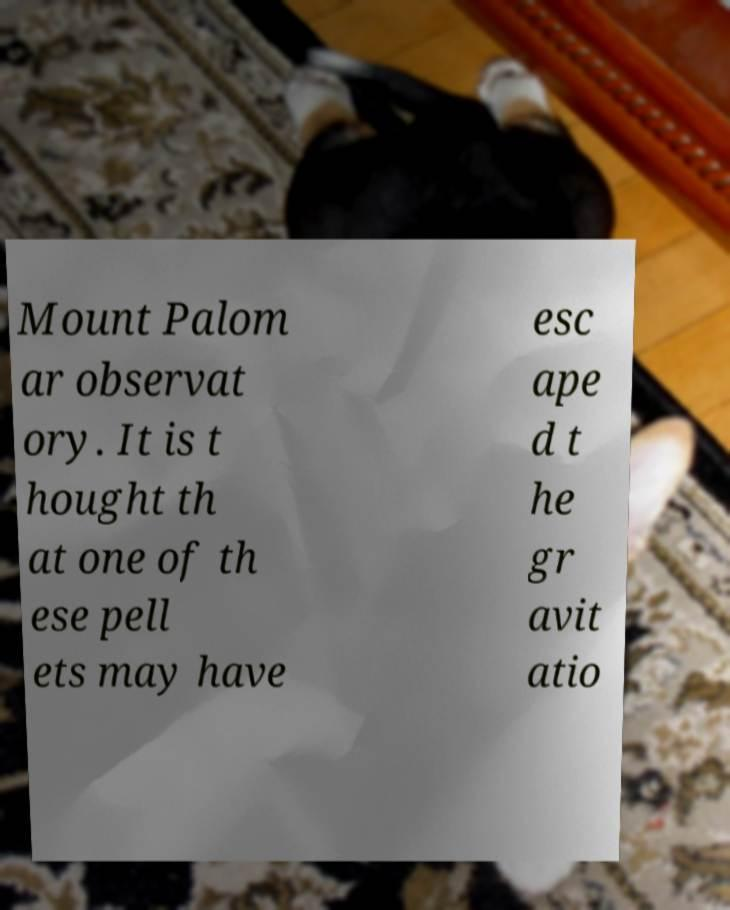Can you read and provide the text displayed in the image?This photo seems to have some interesting text. Can you extract and type it out for me? Mount Palom ar observat ory. It is t hought th at one of th ese pell ets may have esc ape d t he gr avit atio 